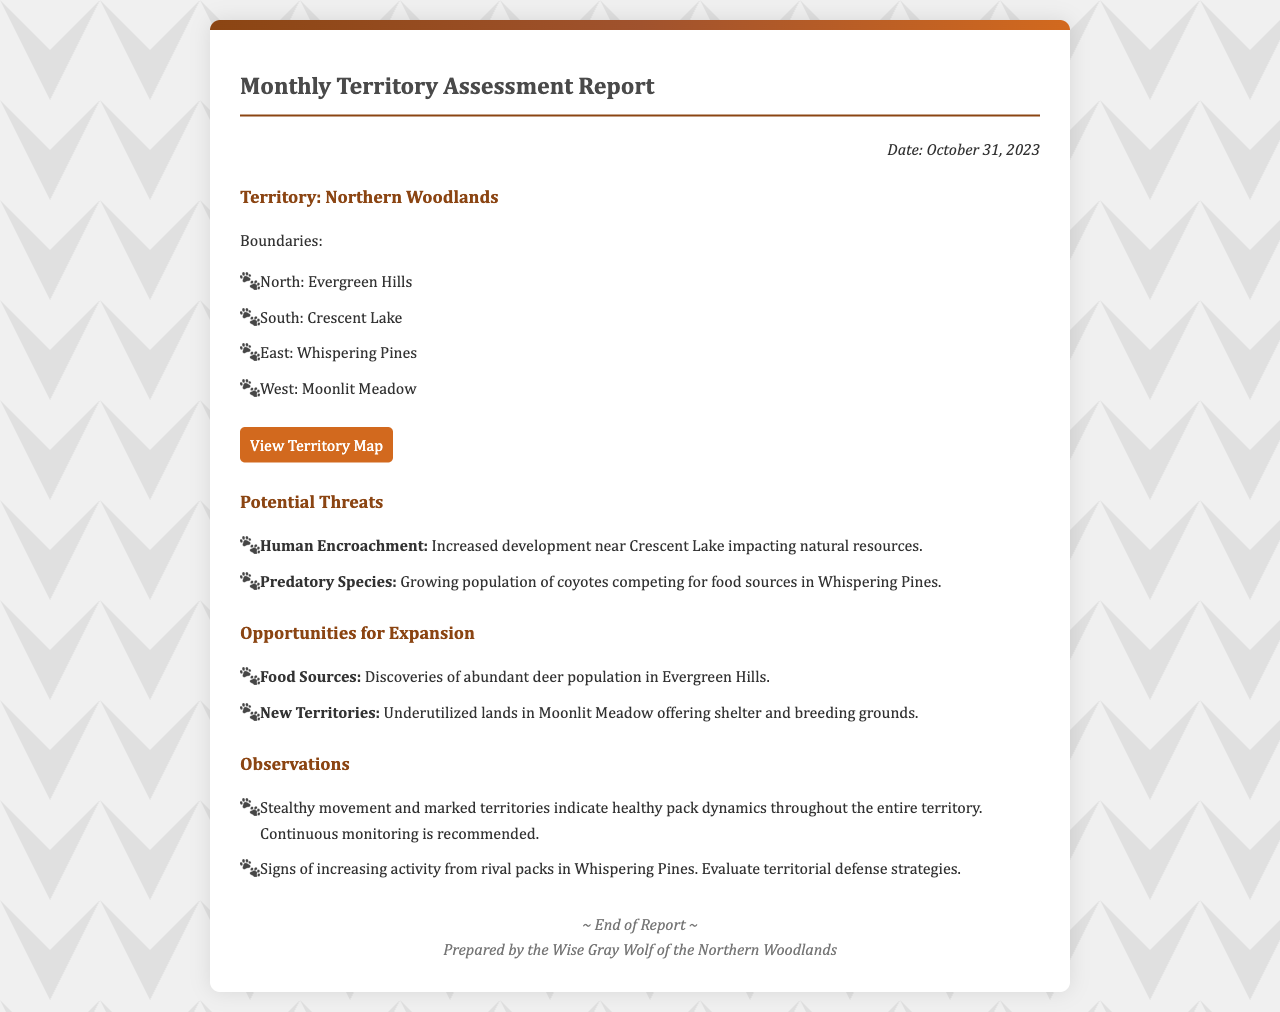what is the date of the report? The date of the report is mentioned clearly at the top of the document, which is October 31, 2023.
Answer: October 31, 2023 what territory is assessed in the report? The territory assessed in the report is specified in the main section heading of the document.
Answer: Northern Woodlands what are the western boundaries of the territory? The western boundary of the territory is listed under the boundaries section in the document.
Answer: Moonlit Meadow name one potential threat mentioned in the report. Potential threats are outlined in a specific section of the document, listing possible dangers to the territory.
Answer: Human Encroachment which areas provide opportunities for expansion? The opportunities for expansion are identified in a dedicated section, specifying areas with potential.
Answer: Moonlit Meadow how many observations are noted in the report? The number of observations can be inferred from the list provided in the observations section of the document.
Answer: Two what does the footer of the document say? The footer contains a specific closing statement revealing who prepared the report.
Answer: Prepared by the Wise Gray Wolf of the Northern Woodlands what are the eastern boundaries of the territory? The eastern boundary is provided in the boundaries listing of the document.
Answer: Whispering Pines 